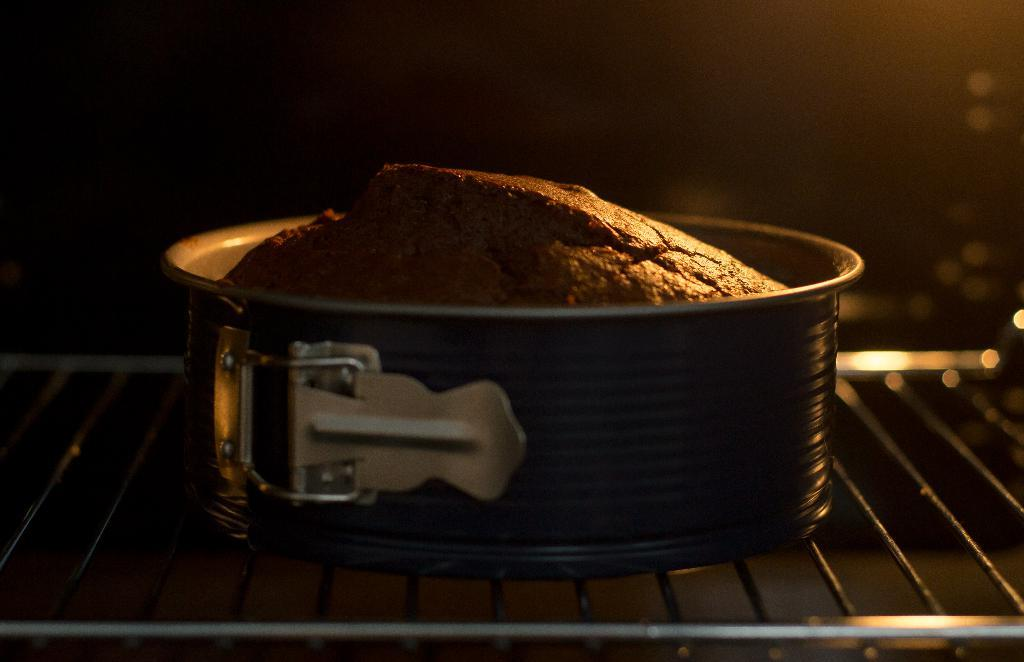What is the main subject of the image? There is a brown baking cake in the image. How is the cake being prepared or cooked? The cake is in a steel bowl, which is placed on a grill. What can be observed about the background of the image? The background of the image is dark. What type of brain can be seen in the image? There is no brain present in the image; it features a brown baking cake in a steel bowl on a grill. How many horses are visible in the image? There are no horses present in the image. 